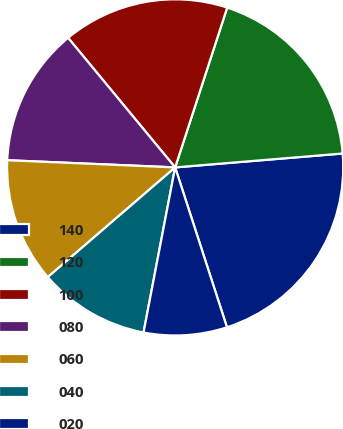<chart> <loc_0><loc_0><loc_500><loc_500><pie_chart><fcel>140<fcel>120<fcel>100<fcel>080<fcel>060<fcel>040<fcel>020<nl><fcel>21.33%<fcel>18.67%<fcel>16.0%<fcel>13.33%<fcel>12.0%<fcel>10.67%<fcel>8.0%<nl></chart> 